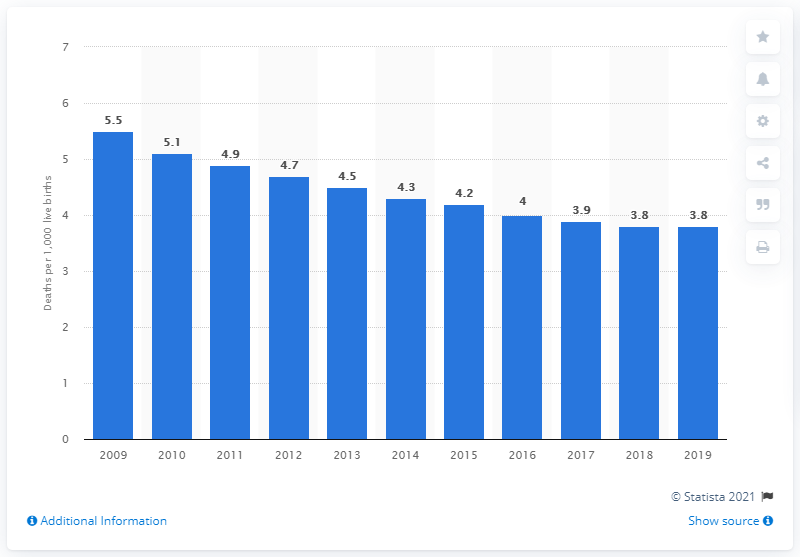Specify some key components in this picture. In 2019, the infant mortality rate in Poland was 3.8. 